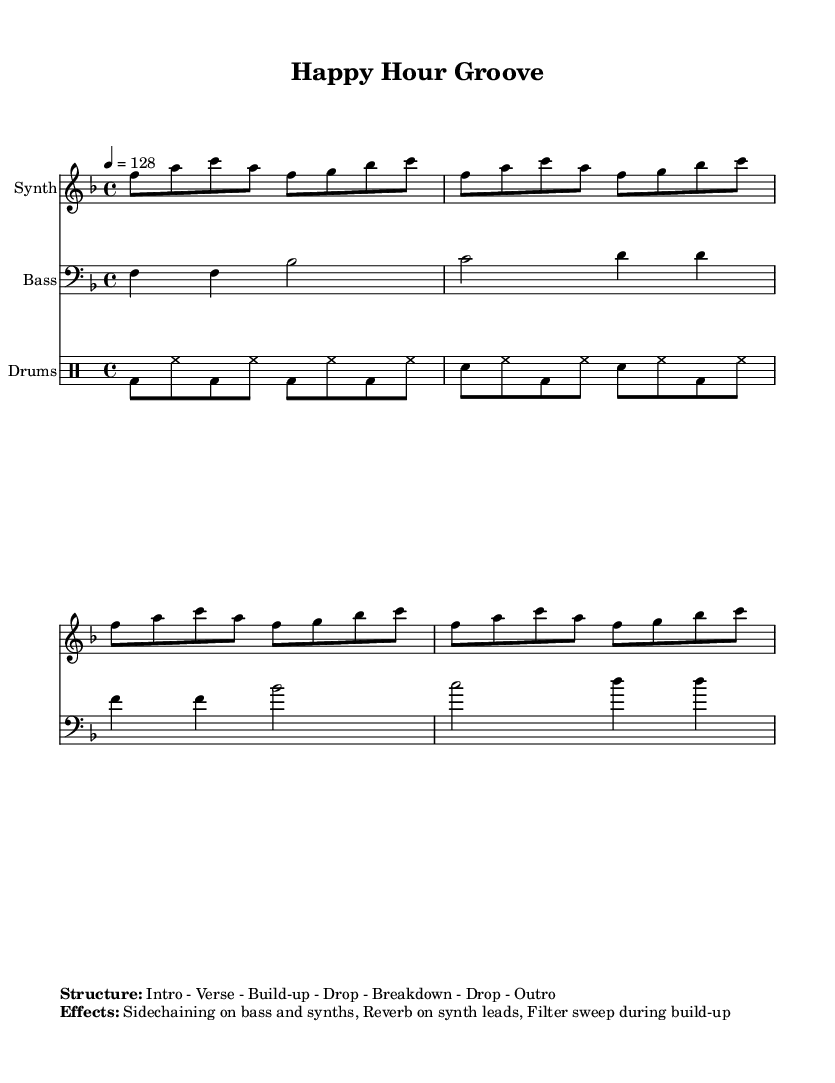What is the key signature of this music? The key signature is F major, which has one flat (B flat).
Answer: F major What is the time signature of this piece? The time signature is 4/4, indicating four beats per measure.
Answer: 4/4 What is the tempo marking in the music sheet? The tempo marking is 128 beats per minute, specifying the speed of the piece.
Answer: 128 How many measures are in the synth part? The synth part contains four measures, as indicated by the repeated pattern of notes.
Answer: Four measures What musical effects are used in this piece? The effects listed include sidechaining on bass and synths, reverb on synth leads, and a filter sweep during the build-up.
Answer: Sidechaining, reverb, filter sweep What is the structure of this piece? The structure listed includes Intro, Verse, Build-up, Drop, Breakdown, Drop, and Outro.
Answer: Intro, Verse, Build-up, Drop, Breakdown, Drop, Outro What type of instruments are included in this score? The score includes a Synth, Bass, and Drums.
Answer: Synth, Bass, Drums 